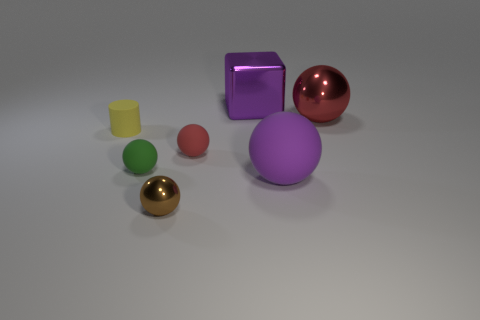Is the number of purple objects that are behind the big red metallic ball greater than the number of big blue rubber cylinders?
Provide a short and direct response. Yes. Is the material of the big block the same as the purple sphere?
Give a very brief answer. No. How many things are either tiny matte objects that are to the left of the green matte object or big gray metal balls?
Make the answer very short. 1. What number of other objects are there of the same size as the yellow matte cylinder?
Give a very brief answer. 3. Are there an equal number of large balls in front of the small brown metallic ball and small metallic balls in front of the green object?
Your response must be concise. No. What is the color of the other tiny matte thing that is the same shape as the tiny green matte thing?
Your response must be concise. Red. Is there any other thing that is the same shape as the purple shiny thing?
Give a very brief answer. No. Do the matte sphere left of the small brown shiny sphere and the small shiny thing have the same color?
Your response must be concise. No. The purple object that is the same shape as the big red metallic object is what size?
Provide a short and direct response. Large. How many other spheres have the same material as the tiny brown ball?
Offer a very short reply. 1. 